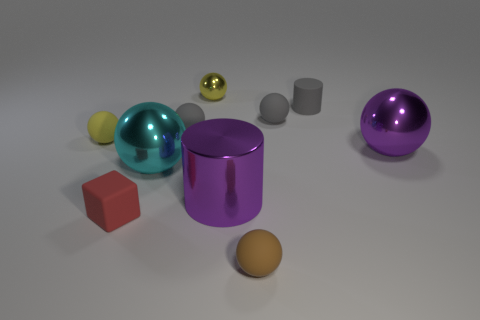What is the color of the matte cylinder that is the same size as the yellow metal thing?
Keep it short and to the point. Gray. How many objects are tiny metal objects or gray matte cylinders?
Make the answer very short. 2. There is a metal thing to the right of the tiny matte sphere that is in front of the large shiny ball that is on the left side of the large purple ball; how big is it?
Provide a succinct answer. Large. What number of blocks have the same color as the matte cylinder?
Offer a terse response. 0. How many large things are the same material as the purple cylinder?
Offer a very short reply. 2. What number of things are either large brown metal balls or metallic balls to the left of the small metal sphere?
Offer a very short reply. 1. What is the color of the shiny object that is behind the ball that is left of the large metallic sphere that is in front of the purple metal sphere?
Ensure brevity in your answer.  Yellow. What size is the gray rubber sphere on the right side of the brown matte thing?
Your answer should be compact. Small. What number of big objects are either purple shiny cylinders or yellow metallic objects?
Your response must be concise. 1. What is the color of the metal object that is in front of the matte cylinder and behind the large cyan metal ball?
Provide a short and direct response. Purple. 